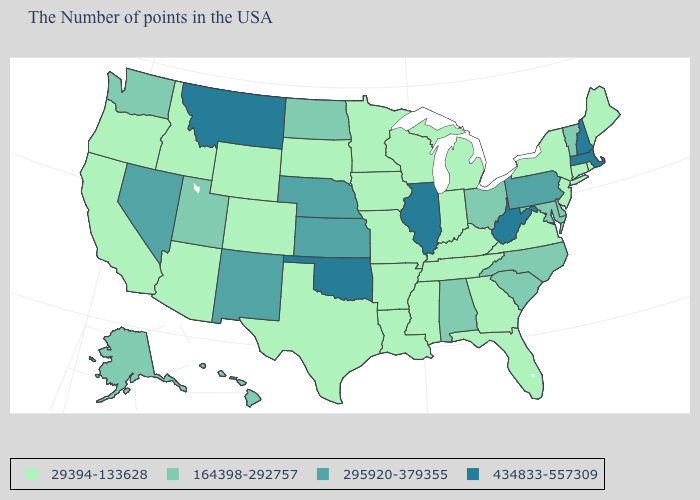What is the value of Louisiana?
Concise answer only. 29394-133628. Name the states that have a value in the range 29394-133628?
Answer briefly. Maine, Rhode Island, Connecticut, New York, New Jersey, Virginia, Florida, Georgia, Michigan, Kentucky, Indiana, Tennessee, Wisconsin, Mississippi, Louisiana, Missouri, Arkansas, Minnesota, Iowa, Texas, South Dakota, Wyoming, Colorado, Arizona, Idaho, California, Oregon. What is the value of Pennsylvania?
Short answer required. 295920-379355. Among the states that border Idaho , which have the highest value?
Answer briefly. Montana. Does New Hampshire have the lowest value in the USA?
Keep it brief. No. What is the lowest value in states that border Washington?
Answer briefly. 29394-133628. Does South Dakota have the lowest value in the USA?
Write a very short answer. Yes. What is the value of Oregon?
Give a very brief answer. 29394-133628. What is the value of Maine?
Be succinct. 29394-133628. Does the map have missing data?
Concise answer only. No. Among the states that border Wisconsin , which have the highest value?
Concise answer only. Illinois. What is the highest value in states that border Utah?
Keep it brief. 295920-379355. What is the highest value in the USA?
Short answer required. 434833-557309. What is the highest value in states that border South Dakota?
Give a very brief answer. 434833-557309. Does Illinois have the highest value in the MidWest?
Quick response, please. Yes. 